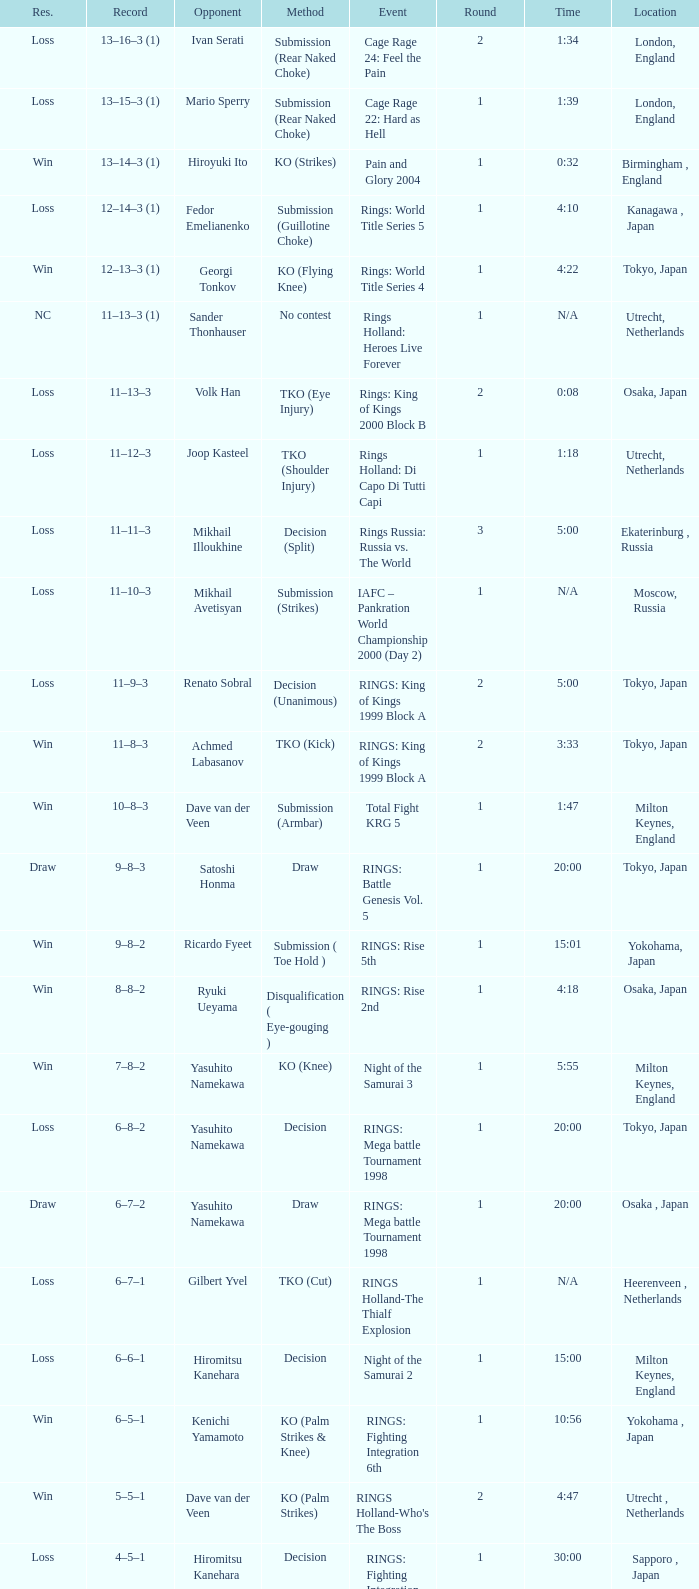In london, england, who was the adversary during a round shorter than 2? Mario Sperry. 